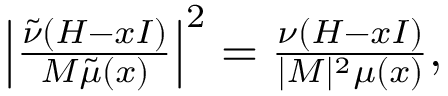<formula> <loc_0><loc_0><loc_500><loc_500>\begin{array} { r } { \left | \frac { \tilde { \nu } ( H - x I ) } { M \tilde { \mu } ( x ) } \right | ^ { 2 } = \frac { \nu ( H - x I ) } { | M | ^ { 2 } \mu ( x ) } , } \end{array}</formula> 